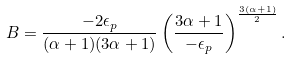<formula> <loc_0><loc_0><loc_500><loc_500>B = \frac { - 2 \epsilon _ { p } } { ( \alpha + 1 ) ( 3 \alpha + 1 ) } \left ( \frac { 3 \alpha + 1 } { - \epsilon _ { p } } \right ) ^ { \frac { 3 ( \alpha + 1 ) } { 2 } } .</formula> 